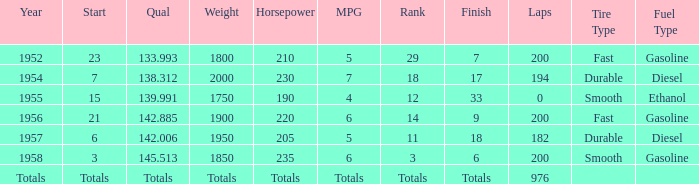What place did Jimmy Reece finish in 1957? 18.0. 